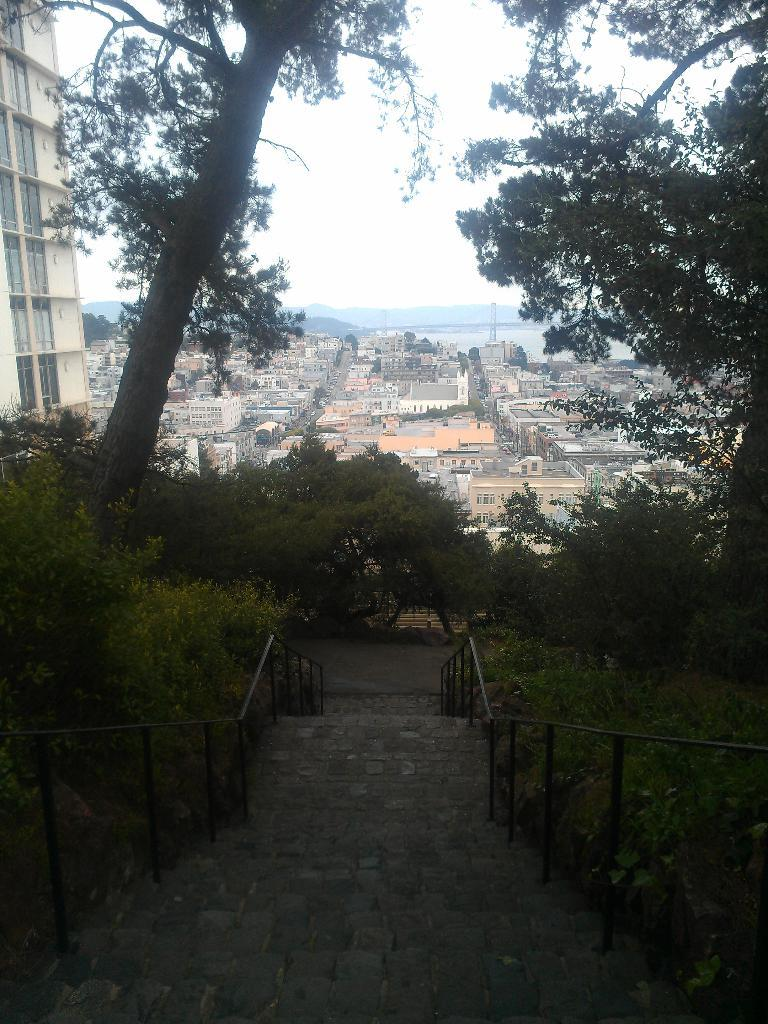What type of structure is present in the image? There are stairs in the image. What can be seen on the left side of the image? There are trees on the left side of the image. What can be seen on the right side of the image? There are trees on the right side of the image. What is visible in the background of the image? There are buildings and the sky visible in the background of the image. What type of order is being given by the person on the swing in the image? There is no person on a swing present in the image. What type of clouds can be seen in the image? The provided facts do not mention any clouds in the image. 